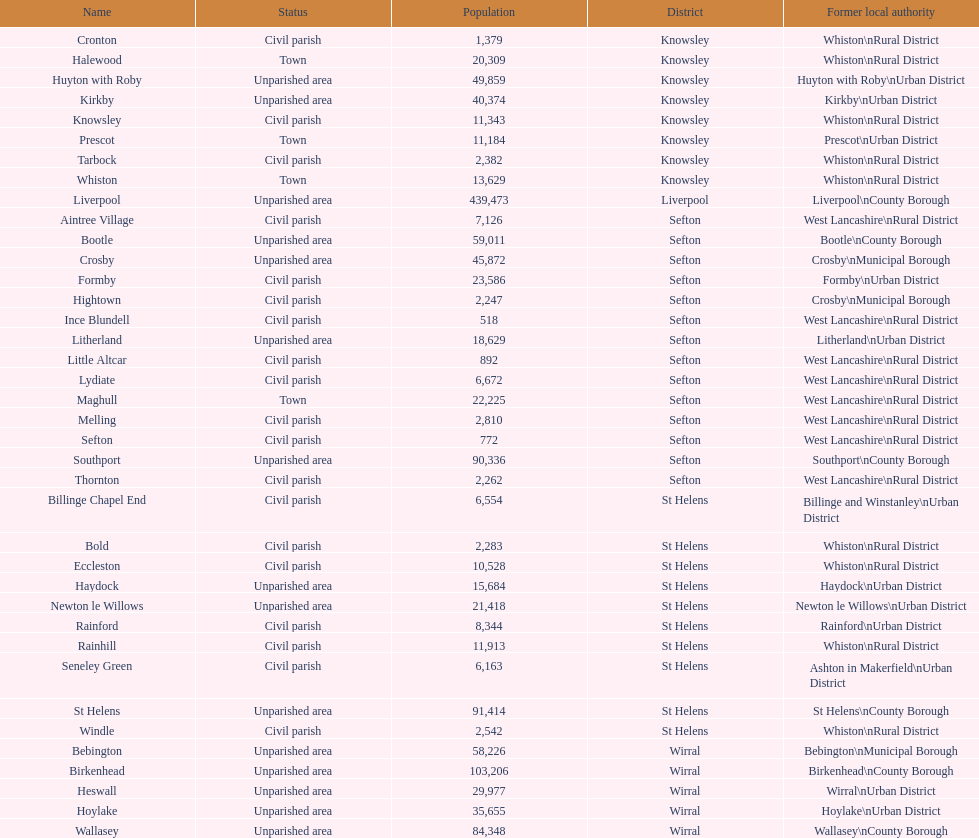How many inhabitants are there in formby? 23,586. 